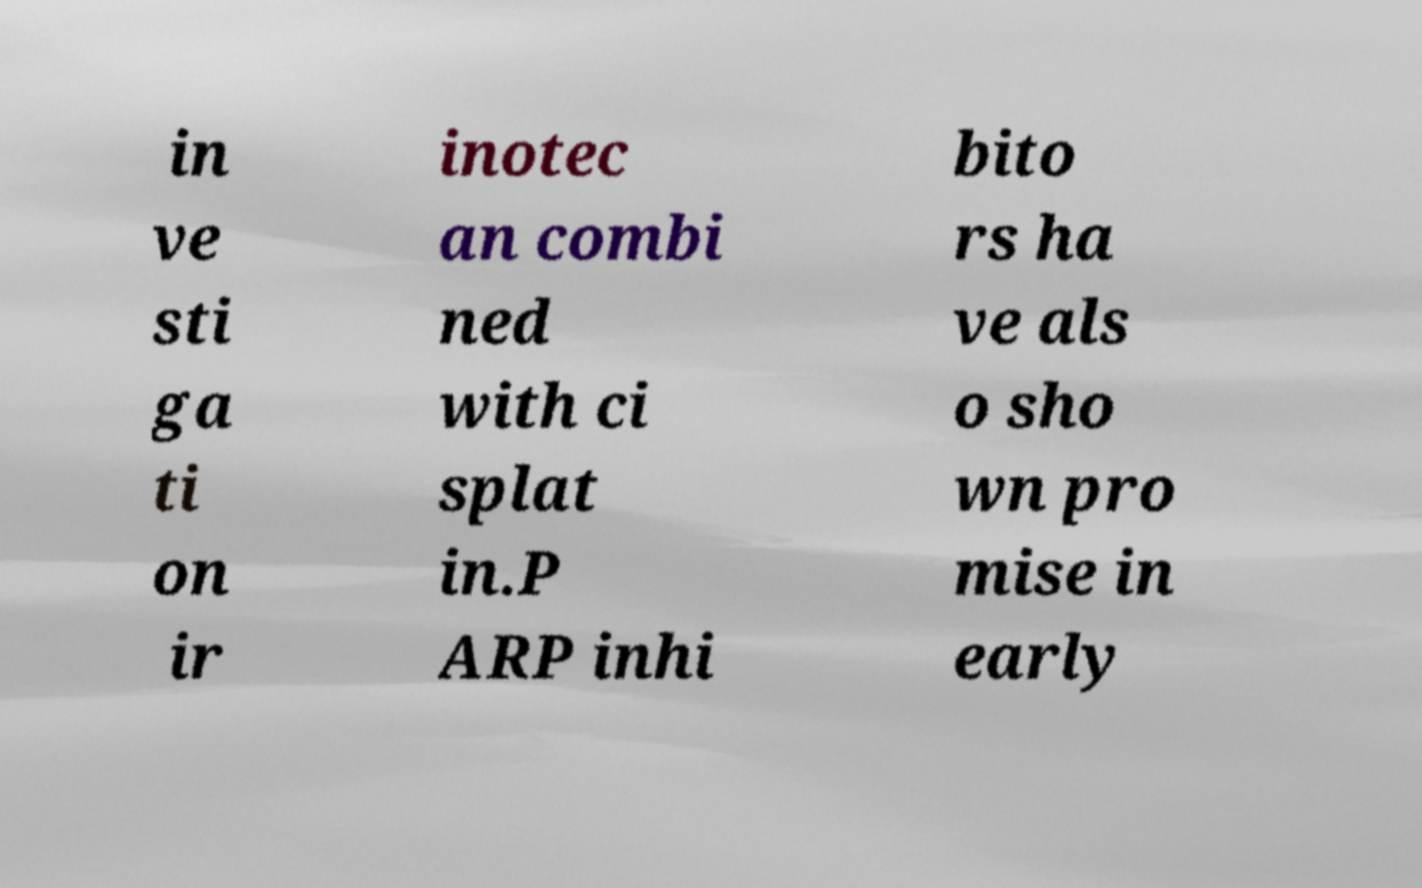Can you accurately transcribe the text from the provided image for me? in ve sti ga ti on ir inotec an combi ned with ci splat in.P ARP inhi bito rs ha ve als o sho wn pro mise in early 